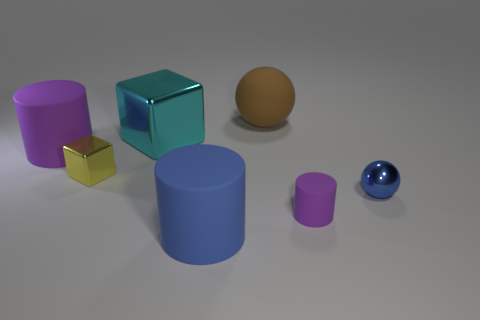Add 2 big brown things. How many objects exist? 9 Subtract all blocks. How many objects are left? 5 Subtract 1 brown spheres. How many objects are left? 6 Subtract all small yellow metallic spheres. Subtract all big cubes. How many objects are left? 6 Add 5 yellow objects. How many yellow objects are left? 6 Add 2 large yellow cubes. How many large yellow cubes exist? 2 